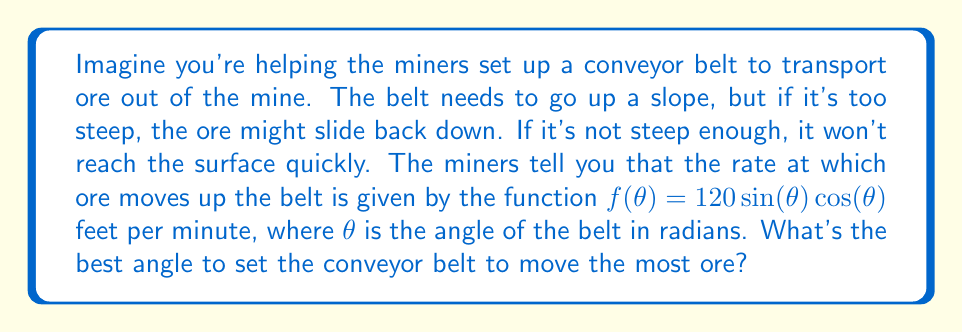What is the answer to this math problem? Let's approach this step-by-step:

1) The function given is $f(\theta) = 120\sin(\theta)\cos(\theta)$. To find the maximum value of this function, we need to find where its derivative equals zero.

2) First, let's simplify the function using the trigonometric identity $\sin(2\theta) = 2\sin(\theta)\cos(\theta)$:

   $f(\theta) = 120\sin(\theta)\cos(\theta) = 60\sin(2\theta)$

3) Now, let's find the derivative of $f(\theta)$:

   $f'(\theta) = 60 \cdot 2\cos(2\theta) = 120\cos(2\theta)$

4) To find the maximum, set $f'(\theta) = 0$:

   $120\cos(2\theta) = 0$
   $\cos(2\theta) = 0$

5) We know that cosine equals zero when its argument is $\frac{\pi}{2}$ or $\frac{3\pi}{2}$. So:

   $2\theta = \frac{\pi}{2}$ or $2\theta = \frac{3\pi}{2}$
   $\theta = \frac{\pi}{4}$ or $\theta = \frac{3\pi}{4}$

6) To determine which of these gives a maximum (not a minimum), we can check the second derivative:

   $f''(\theta) = 120 \cdot -2\sin(2\theta) = -240\sin(2\theta)$

   At $\theta = \frac{\pi}{4}$, $f''(\frac{\pi}{4}) = -240\sin(\frac{\pi}{2}) = -240 < 0$, confirming this is a maximum.

7) Convert $\frac{\pi}{4}$ radians to degrees:

   $\frac{\pi}{4} \cdot \frac{180^{\circ}}{\pi} = 45^{\circ}$

Therefore, the optimal angle for the conveyor belt is 45°.
Answer: 45° 